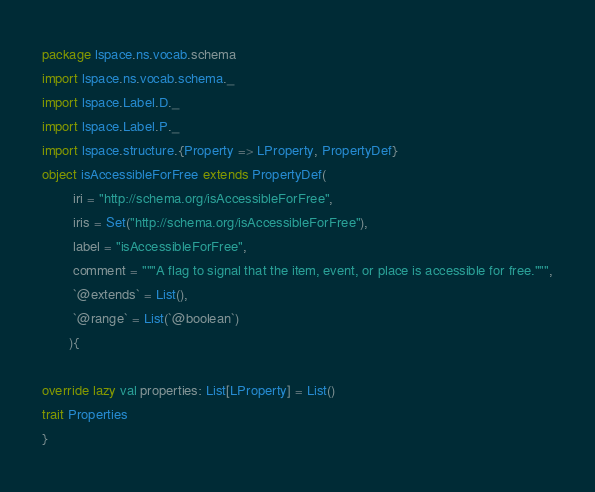Convert code to text. <code><loc_0><loc_0><loc_500><loc_500><_Scala_>package lspace.ns.vocab.schema
import lspace.ns.vocab.schema._
import lspace.Label.D._
import lspace.Label.P._
import lspace.structure.{Property => LProperty, PropertyDef}
object isAccessibleForFree extends PropertyDef(
        iri = "http://schema.org/isAccessibleForFree",
        iris = Set("http://schema.org/isAccessibleForFree"),
        label = "isAccessibleForFree",
        comment = """A flag to signal that the item, event, or place is accessible for free.""",
        `@extends` = List(),
        `@range` = List(`@boolean`)
       ){

override lazy val properties: List[LProperty] = List()
trait Properties 
}</code> 